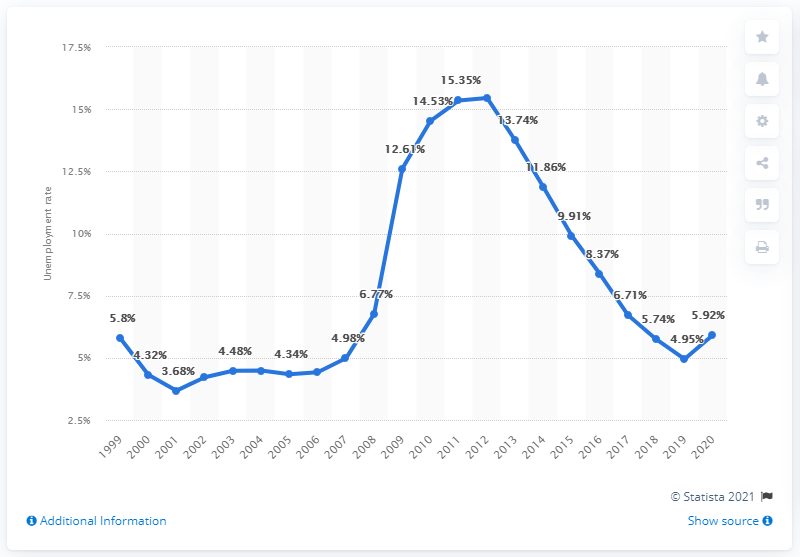Specify some key components in this picture. In 2020, the unemployment rate in Ireland was 5.92%. 